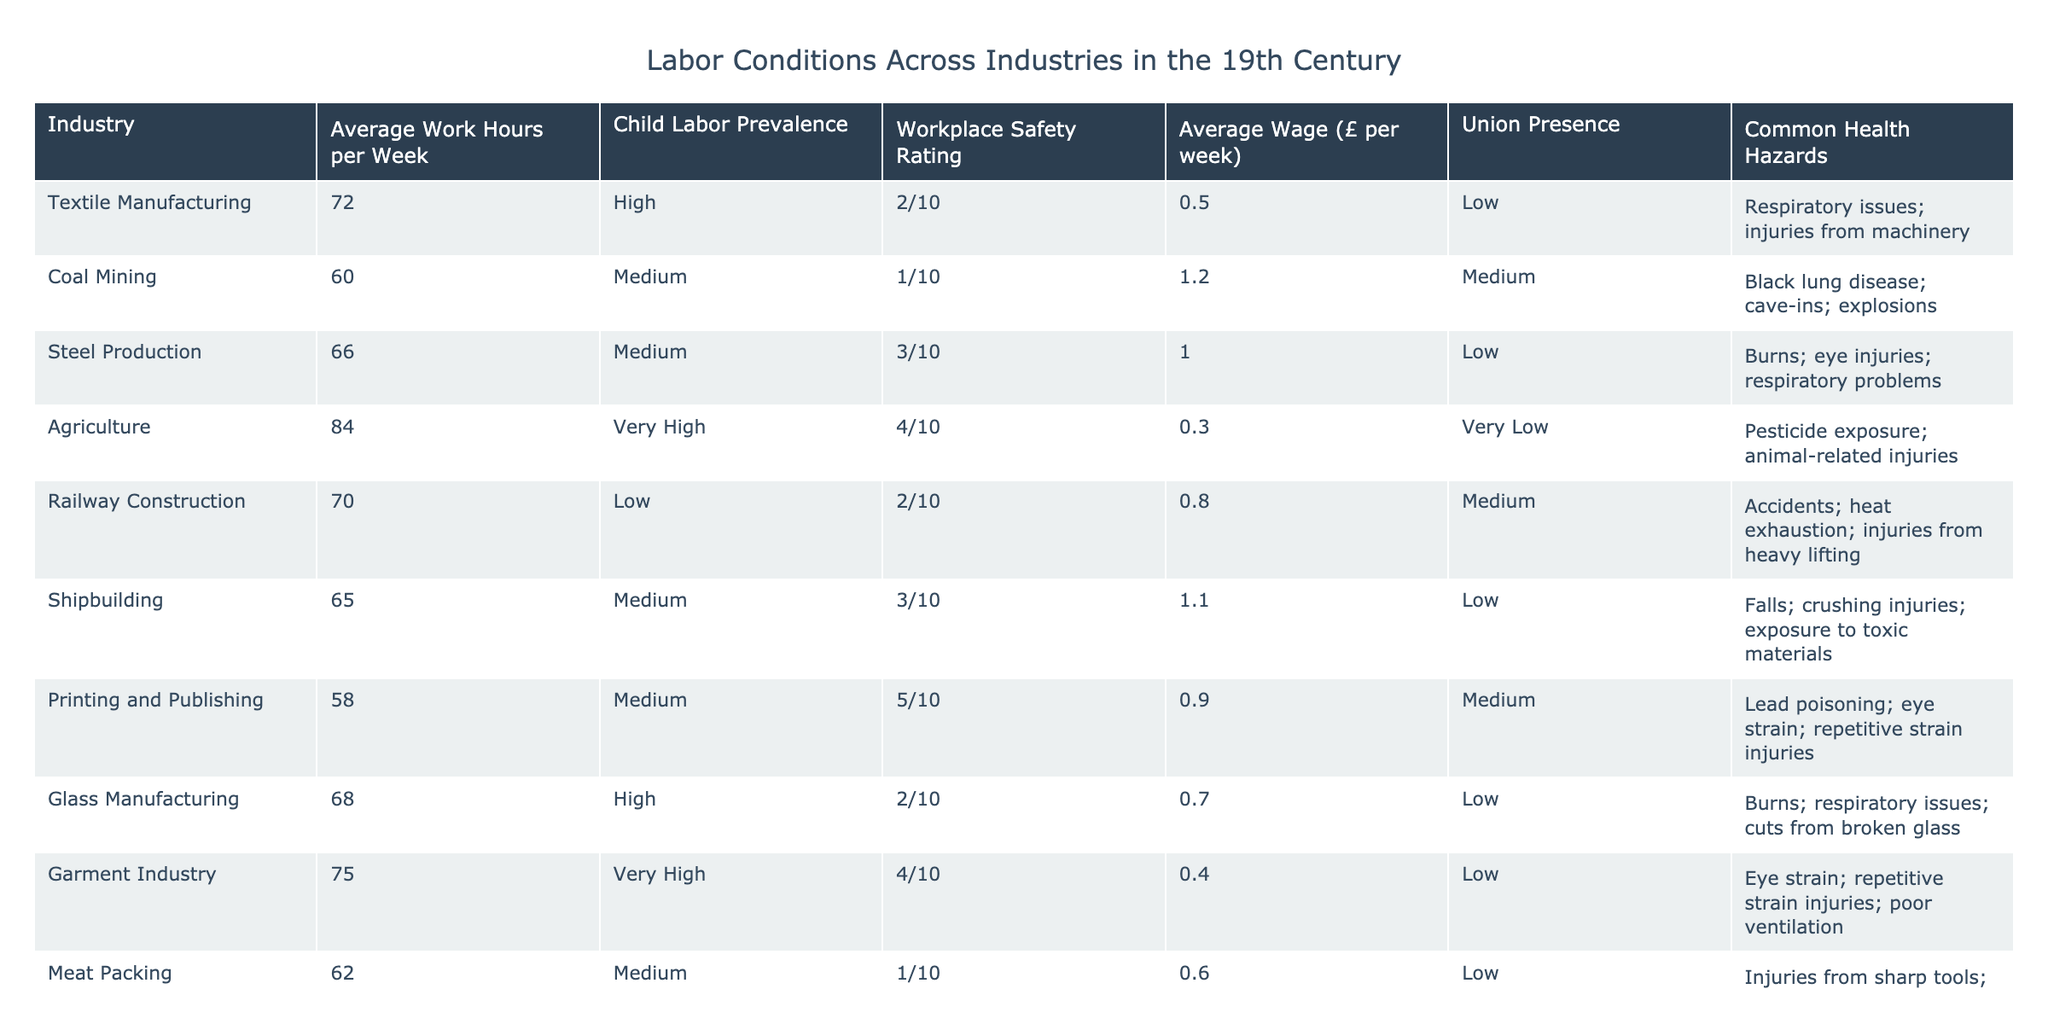What is the average work hours per week in the textile manufacturing industry? According to the table, the average work hours per week in textile manufacturing is directly listed as 72.
Answer: 72 Which industry has the highest prevalence of child labor? The table shows that agriculture has a prevalence of child labor categorized as "Very High" (4/10), which is higher than any other industry listed.
Answer: Agriculture What is the average wage in the coal mining industry? The table lists the average wage for coal mining as £1.2 per week.
Answer: 1.2 Is the union presence in the garment industry low? The table indicates that the garment industry has a union presence rated as "Low," therefore it is true.
Answer: Yes What are the common health hazards associated with the meat packing industry? The table specifies the common health hazards for the meat packing industry as "Injuries from sharp tools; exposure to pathogens; cold-related illnesses," listing three types of hazards.
Answer: Injuries from sharp tools; exposure to pathogens; cold-related illnesses Calculate the total average work hours per week for both the textile manufacturing and garment industries. The average work hours for textile manufacturing is 72, and for garment industry it is 75. Summing them up gives 72 + 75 = 147 work hours per week for both industries combined.
Answer: 147 Which industry has better workplace safety ratings, glass manufacturing or shipbuilding? Comparing their workplace safety ratings from the table, glass manufacturing has a rating of 2/10 and shipbuilding has a rating of 3/10. Since 3 is greater than 2, shipbuilding has better workplace safety.
Answer: Shipbuilding Does the average wage for printing and publishing justify the high safety rating? The average wage for printing and publishing is £0.9 with a safety rating of 5/10. There is no straightforward method to justify the wage against the rating, but a higher safety rating typically shouldn't accompany a low wage, making the justification questionable.
Answer: No Which industry works fewer average hours per week: railway construction or printing and publishing? Railway construction averages 70 hours per week, while printing and publishing averages 58 hours. Thus, printing and publishing works fewer hours per week than railway construction.
Answer: Printing and publishing 